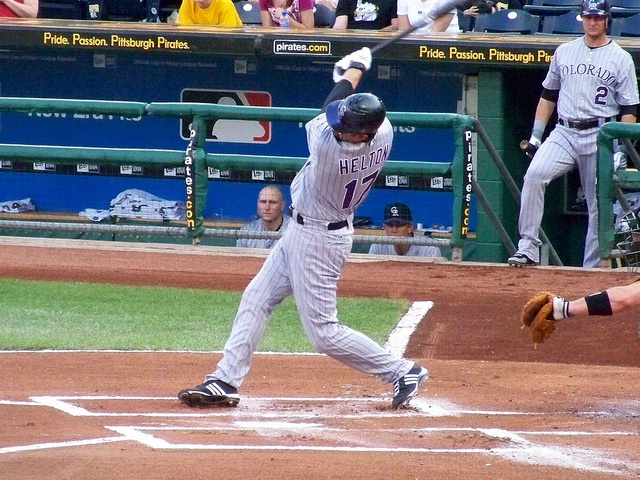Describe the objects in this image and their specific colors. I can see people in brown, lavender, black, and darkgray tones, people in brown, lavender, darkgray, and gray tones, baseball glove in brown and maroon tones, and baseball bat in brown, gray, darkgray, and lavender tones in this image. 